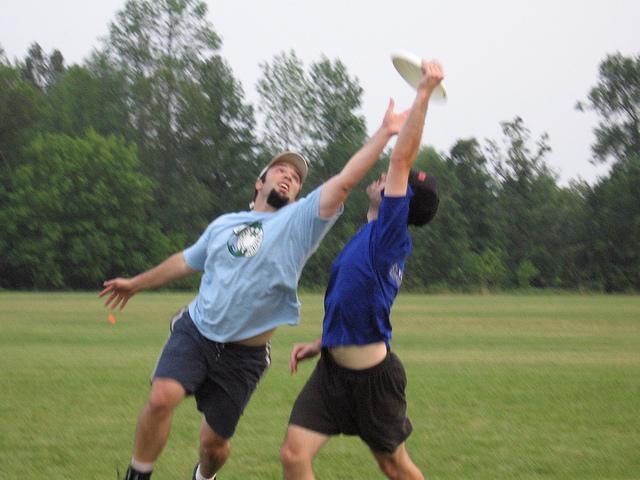How many people are wearing shorts?
Give a very brief answer. 2. How many people are there?
Give a very brief answer. 2. 